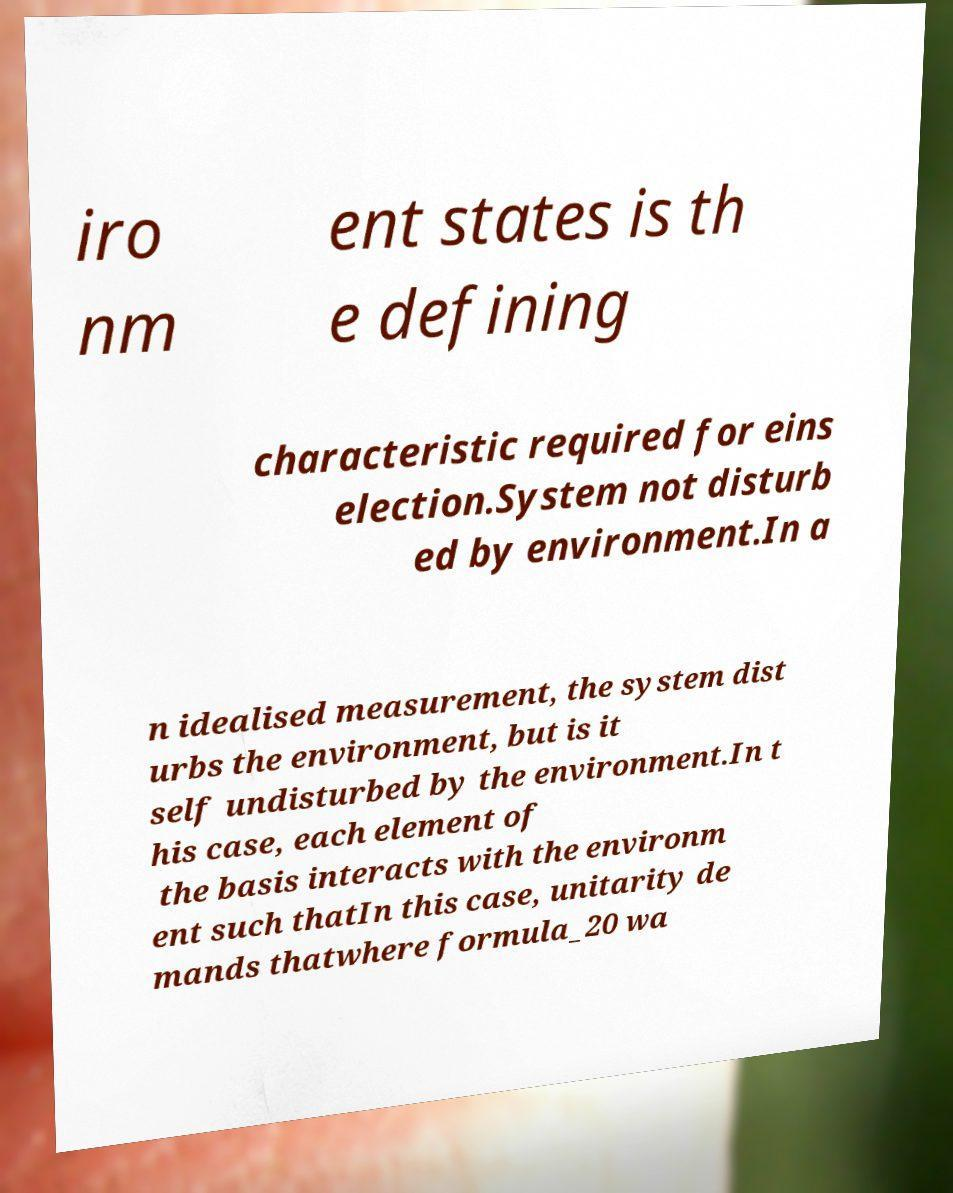Could you assist in decoding the text presented in this image and type it out clearly? iro nm ent states is th e defining characteristic required for eins election.System not disturb ed by environment.In a n idealised measurement, the system dist urbs the environment, but is it self undisturbed by the environment.In t his case, each element of the basis interacts with the environm ent such thatIn this case, unitarity de mands thatwhere formula_20 wa 